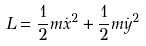<formula> <loc_0><loc_0><loc_500><loc_500>L = \frac { 1 } { 2 } m \dot { x } ^ { 2 } + \frac { 1 } { 2 } m \dot { y } ^ { 2 }</formula> 